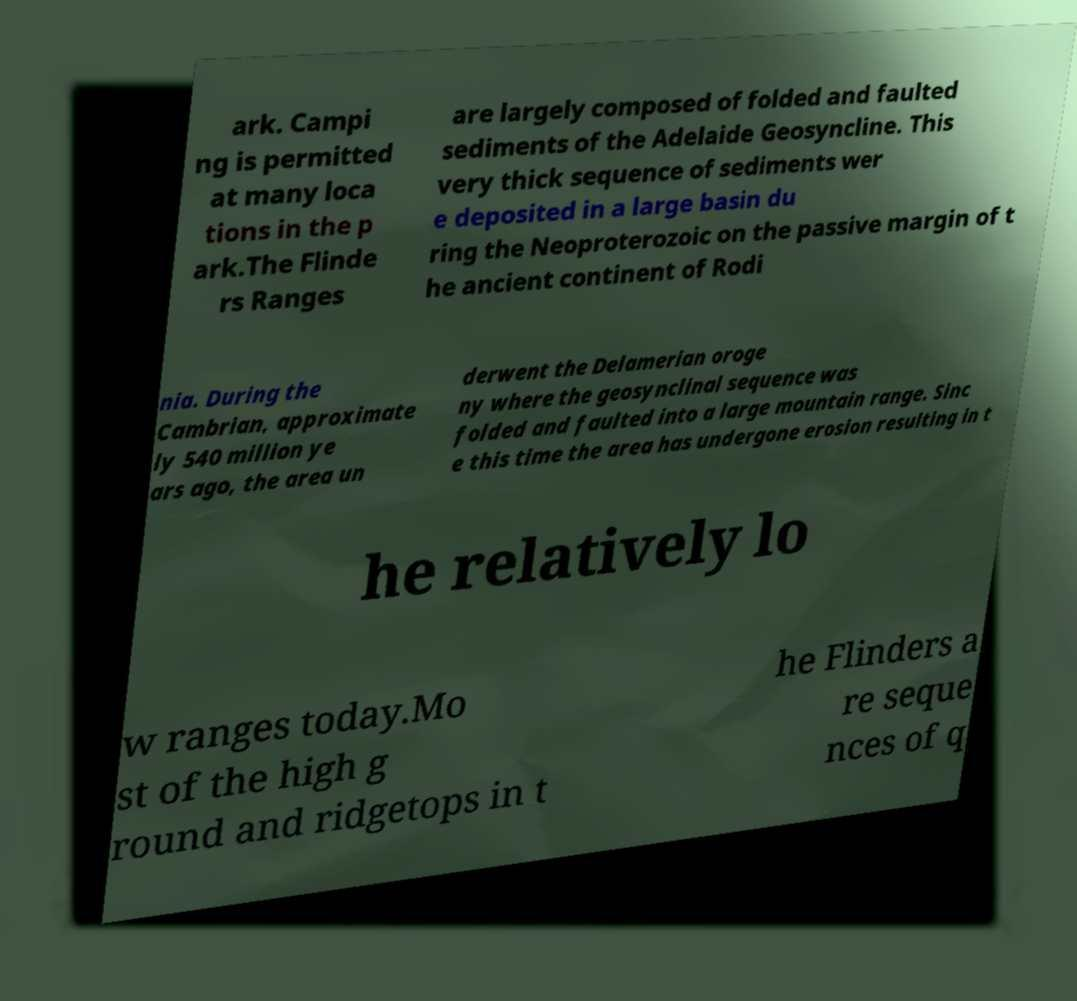For documentation purposes, I need the text within this image transcribed. Could you provide that? ark. Campi ng is permitted at many loca tions in the p ark.The Flinde rs Ranges are largely composed of folded and faulted sediments of the Adelaide Geosyncline. This very thick sequence of sediments wer e deposited in a large basin du ring the Neoproterozoic on the passive margin of t he ancient continent of Rodi nia. During the Cambrian, approximate ly 540 million ye ars ago, the area un derwent the Delamerian oroge ny where the geosynclinal sequence was folded and faulted into a large mountain range. Sinc e this time the area has undergone erosion resulting in t he relatively lo w ranges today.Mo st of the high g round and ridgetops in t he Flinders a re seque nces of q 